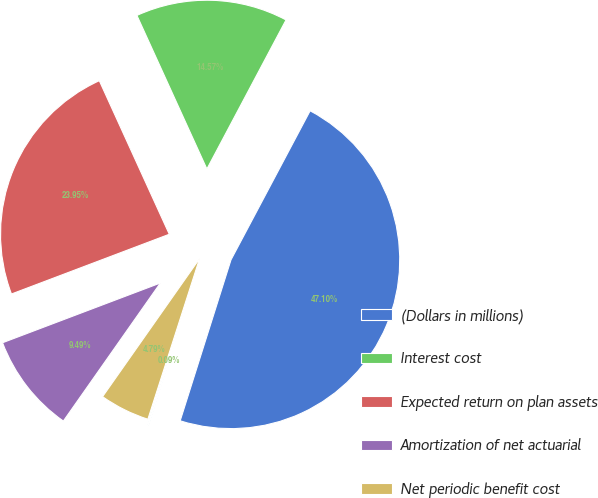<chart> <loc_0><loc_0><loc_500><loc_500><pie_chart><fcel>(Dollars in millions)<fcel>Interest cost<fcel>Expected return on plan assets<fcel>Amortization of net actuarial<fcel>Net periodic benefit cost<fcel>Discount rate<nl><fcel>47.09%<fcel>14.57%<fcel>23.95%<fcel>9.49%<fcel>4.79%<fcel>0.09%<nl></chart> 